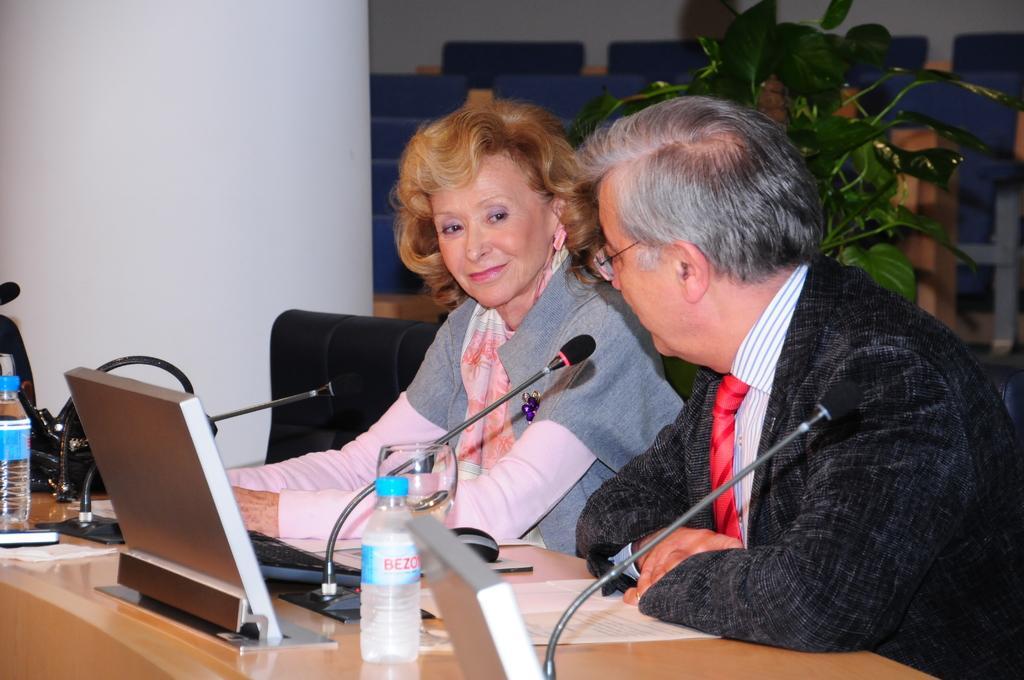Could you give a brief overview of what you see in this image? In this image I can see two persons are sitting on the chairs in front of a table on which I can see mikes, bottles, bag and papers. In the background I can see a wall, chairs, houseplant and a pillar. This image is taken may be in a hall. 